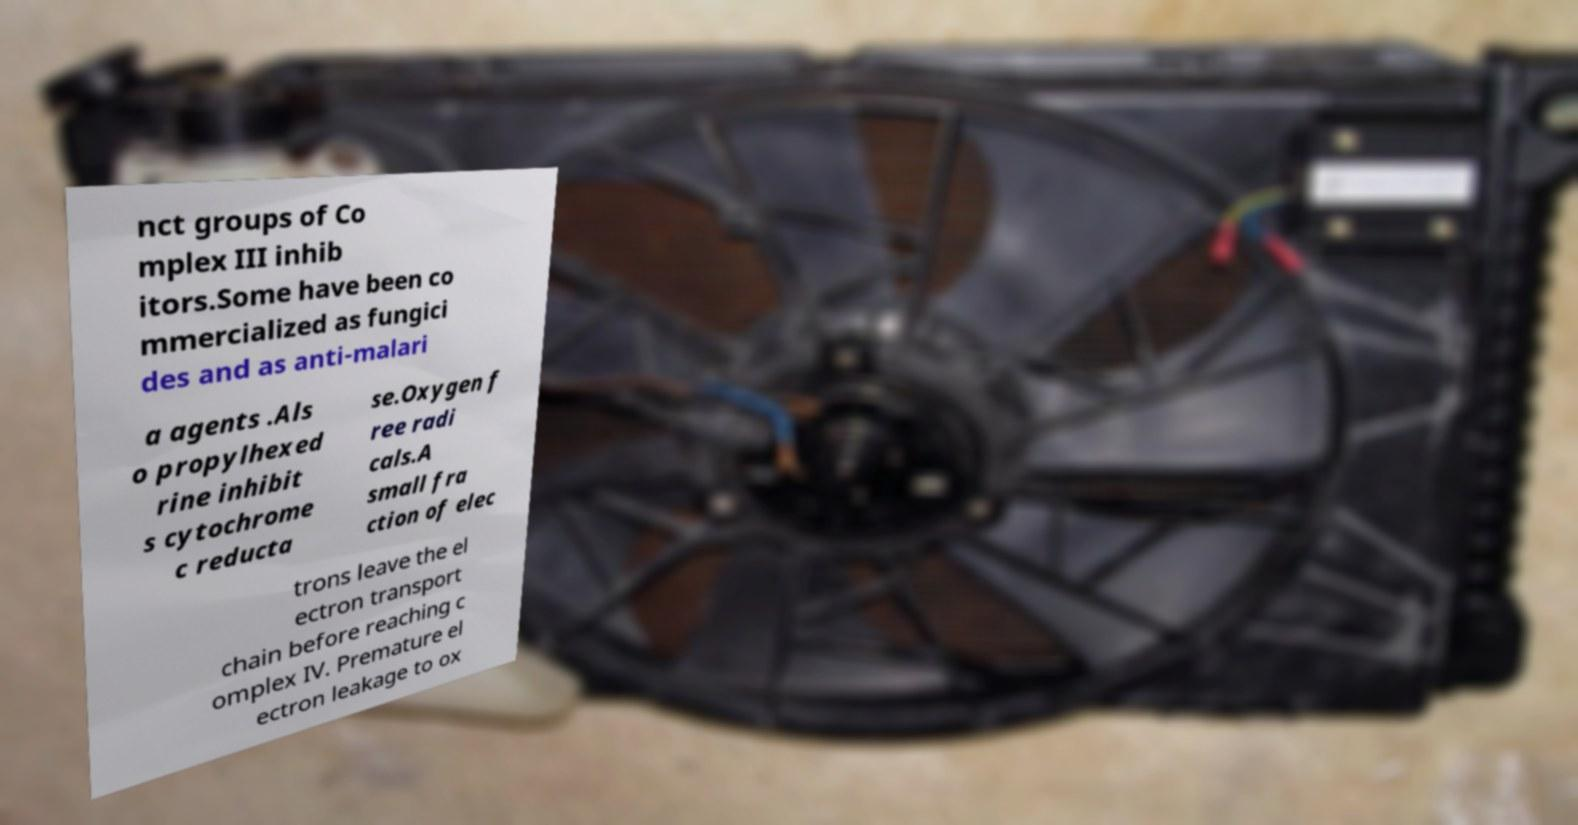Could you extract and type out the text from this image? nct groups of Co mplex III inhib itors.Some have been co mmercialized as fungici des and as anti-malari a agents .Als o propylhexed rine inhibit s cytochrome c reducta se.Oxygen f ree radi cals.A small fra ction of elec trons leave the el ectron transport chain before reaching c omplex IV. Premature el ectron leakage to ox 